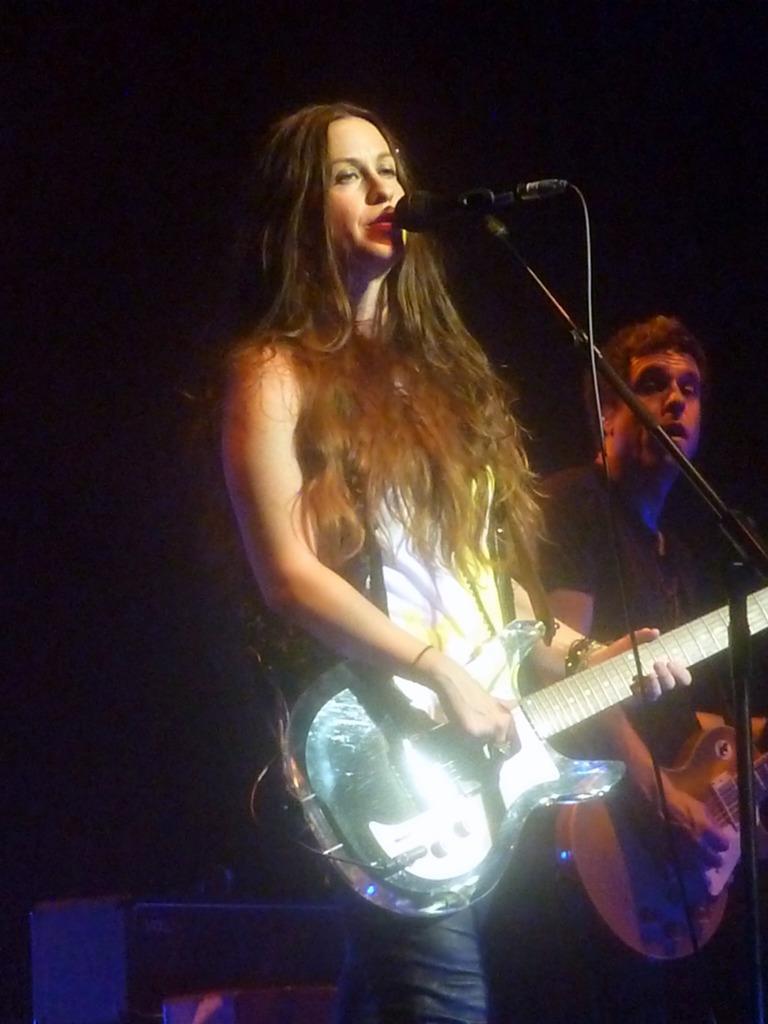Please provide a concise description of this image. In the picture we can see a woman holding a guitar and singing a song in the microphone just beside to her there is a man standing and holding a guitar. In the background there is dark. 